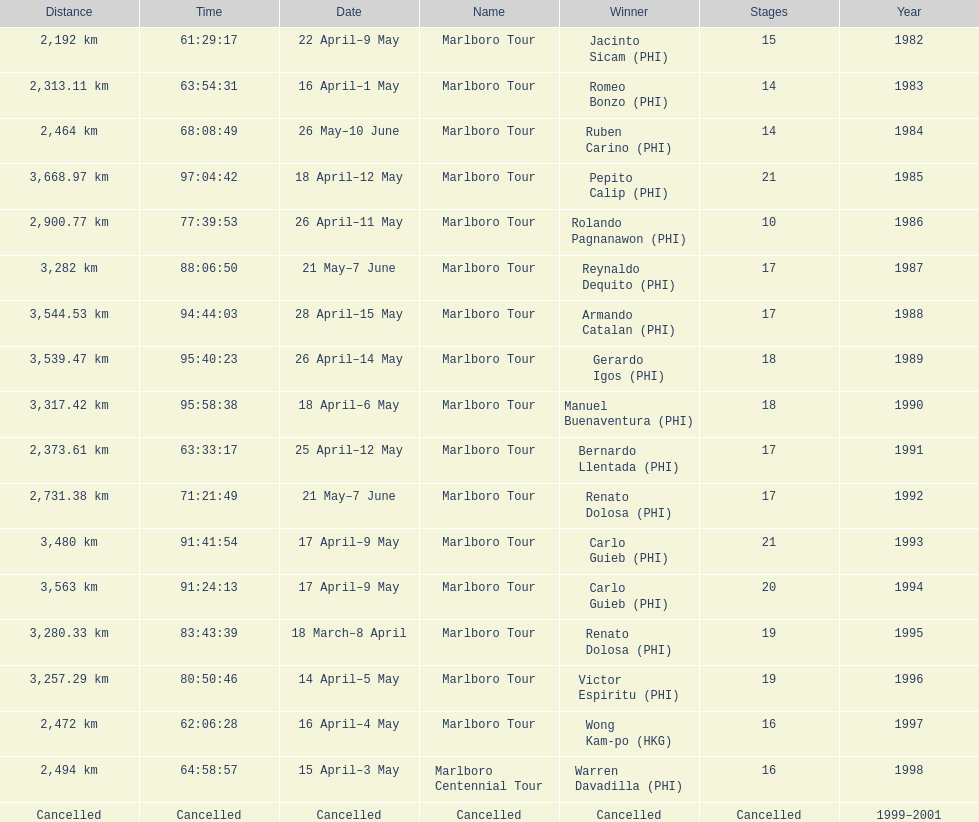Would you mind parsing the complete table? {'header': ['Distance', 'Time', 'Date', 'Name', 'Winner', 'Stages', 'Year'], 'rows': [['2,192\xa0km', '61:29:17', '22 April–9 May', 'Marlboro Tour', 'Jacinto Sicam\xa0(PHI)', '15', '1982'], ['2,313.11\xa0km', '63:54:31', '16 April–1 May', 'Marlboro Tour', 'Romeo Bonzo\xa0(PHI)', '14', '1983'], ['2,464\xa0km', '68:08:49', '26 May–10 June', 'Marlboro Tour', 'Ruben Carino\xa0(PHI)', '14', '1984'], ['3,668.97\xa0km', '97:04:42', '18 April–12 May', 'Marlboro Tour', 'Pepito Calip\xa0(PHI)', '21', '1985'], ['2,900.77\xa0km', '77:39:53', '26 April–11 May', 'Marlboro Tour', 'Rolando Pagnanawon\xa0(PHI)', '10', '1986'], ['3,282\xa0km', '88:06:50', '21 May–7 June', 'Marlboro Tour', 'Reynaldo Dequito\xa0(PHI)', '17', '1987'], ['3,544.53\xa0km', '94:44:03', '28 April–15 May', 'Marlboro Tour', 'Armando Catalan\xa0(PHI)', '17', '1988'], ['3,539.47\xa0km', '95:40:23', '26 April–14 May', 'Marlboro Tour', 'Gerardo Igos\xa0(PHI)', '18', '1989'], ['3,317.42\xa0km', '95:58:38', '18 April–6 May', 'Marlboro Tour', 'Manuel Buenaventura\xa0(PHI)', '18', '1990'], ['2,373.61\xa0km', '63:33:17', '25 April–12 May', 'Marlboro Tour', 'Bernardo Llentada\xa0(PHI)', '17', '1991'], ['2,731.38\xa0km', '71:21:49', '21 May–7 June', 'Marlboro Tour', 'Renato Dolosa\xa0(PHI)', '17', '1992'], ['3,480\xa0km', '91:41:54', '17 April–9 May', 'Marlboro Tour', 'Carlo Guieb\xa0(PHI)', '21', '1993'], ['3,563\xa0km', '91:24:13', '17 April–9 May', 'Marlboro Tour', 'Carlo Guieb\xa0(PHI)', '20', '1994'], ['3,280.33\xa0km', '83:43:39', '18 March–8 April', 'Marlboro Tour', 'Renato Dolosa\xa0(PHI)', '19', '1995'], ['3,257.29\xa0km', '80:50:46', '14 April–5 May', 'Marlboro Tour', 'Victor Espiritu\xa0(PHI)', '19', '1996'], ['2,472\xa0km', '62:06:28', '16 April–4 May', 'Marlboro Tour', 'Wong Kam-po\xa0(HKG)', '16', '1997'], ['2,494\xa0km', '64:58:57', '15 April–3 May', 'Marlboro Centennial Tour', 'Warren Davadilla\xa0(PHI)', '16', '1998'], ['Cancelled', 'Cancelled', 'Cancelled', 'Cancelled', 'Cancelled', 'Cancelled', '1999–2001']]} Who was the only winner to have their time below 61:45:00? Jacinto Sicam. 